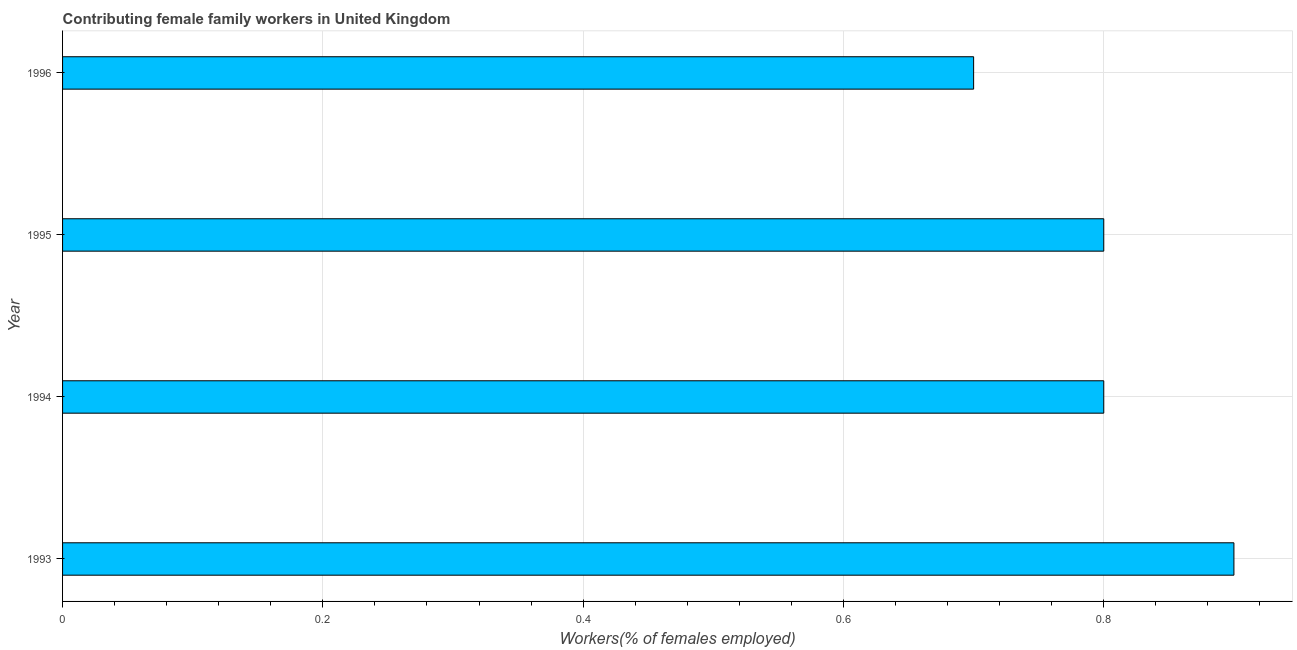Does the graph contain any zero values?
Ensure brevity in your answer.  No. Does the graph contain grids?
Offer a terse response. Yes. What is the title of the graph?
Give a very brief answer. Contributing female family workers in United Kingdom. What is the label or title of the X-axis?
Offer a terse response. Workers(% of females employed). What is the contributing female family workers in 1995?
Ensure brevity in your answer.  0.8. Across all years, what is the maximum contributing female family workers?
Offer a terse response. 0.9. Across all years, what is the minimum contributing female family workers?
Offer a terse response. 0.7. In which year was the contributing female family workers minimum?
Give a very brief answer. 1996. What is the sum of the contributing female family workers?
Make the answer very short. 3.2. What is the difference between the contributing female family workers in 1993 and 1996?
Offer a terse response. 0.2. What is the median contributing female family workers?
Offer a terse response. 0.8. What is the ratio of the contributing female family workers in 1994 to that in 1996?
Your response must be concise. 1.14. Is the contributing female family workers in 1995 less than that in 1996?
Offer a very short reply. No. Is the difference between the contributing female family workers in 1994 and 1996 greater than the difference between any two years?
Offer a very short reply. No. What is the difference between the highest and the second highest contributing female family workers?
Ensure brevity in your answer.  0.1. Is the sum of the contributing female family workers in 1993 and 1995 greater than the maximum contributing female family workers across all years?
Provide a short and direct response. Yes. What is the difference between the highest and the lowest contributing female family workers?
Provide a succinct answer. 0.2. How many bars are there?
Keep it short and to the point. 4. Are all the bars in the graph horizontal?
Keep it short and to the point. Yes. What is the difference between two consecutive major ticks on the X-axis?
Your response must be concise. 0.2. What is the Workers(% of females employed) in 1993?
Offer a terse response. 0.9. What is the Workers(% of females employed) of 1994?
Give a very brief answer. 0.8. What is the Workers(% of females employed) in 1995?
Your answer should be very brief. 0.8. What is the Workers(% of females employed) of 1996?
Offer a very short reply. 0.7. What is the difference between the Workers(% of females employed) in 1993 and 1995?
Give a very brief answer. 0.1. What is the difference between the Workers(% of females employed) in 1994 and 1995?
Offer a very short reply. 0. What is the difference between the Workers(% of females employed) in 1994 and 1996?
Make the answer very short. 0.1. What is the ratio of the Workers(% of females employed) in 1993 to that in 1995?
Your answer should be very brief. 1.12. What is the ratio of the Workers(% of females employed) in 1993 to that in 1996?
Provide a succinct answer. 1.29. What is the ratio of the Workers(% of females employed) in 1994 to that in 1995?
Offer a very short reply. 1. What is the ratio of the Workers(% of females employed) in 1994 to that in 1996?
Your answer should be very brief. 1.14. What is the ratio of the Workers(% of females employed) in 1995 to that in 1996?
Ensure brevity in your answer.  1.14. 